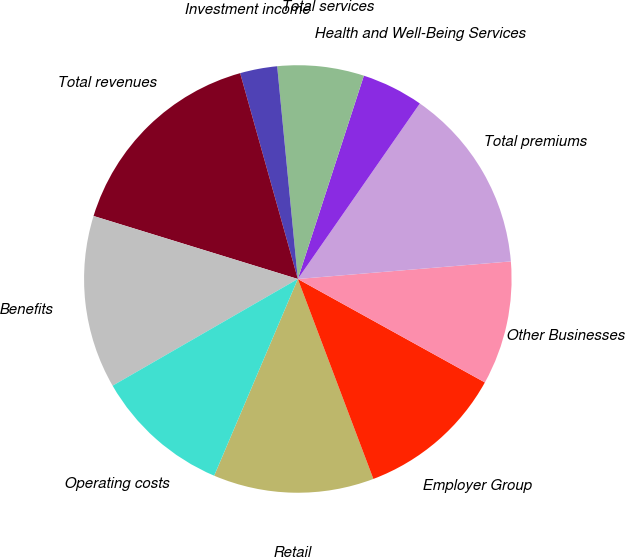Convert chart to OTSL. <chart><loc_0><loc_0><loc_500><loc_500><pie_chart><fcel>Retail<fcel>Employer Group<fcel>Other Businesses<fcel>Total premiums<fcel>Health and Well-Being Services<fcel>Total services<fcel>Investment income<fcel>Total revenues<fcel>Benefits<fcel>Operating costs<nl><fcel>12.15%<fcel>11.21%<fcel>9.35%<fcel>14.02%<fcel>4.67%<fcel>6.54%<fcel>2.81%<fcel>15.89%<fcel>13.08%<fcel>10.28%<nl></chart> 